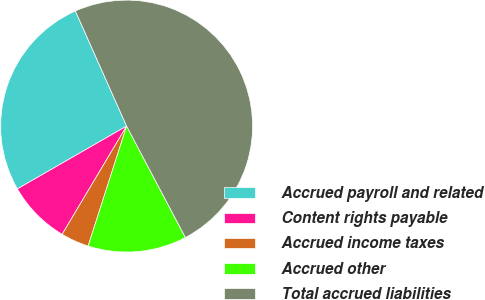<chart> <loc_0><loc_0><loc_500><loc_500><pie_chart><fcel>Accrued payroll and related<fcel>Content rights payable<fcel>Accrued income taxes<fcel>Accrued other<fcel>Total accrued liabilities<nl><fcel>26.64%<fcel>8.14%<fcel>3.61%<fcel>12.67%<fcel>48.93%<nl></chart> 